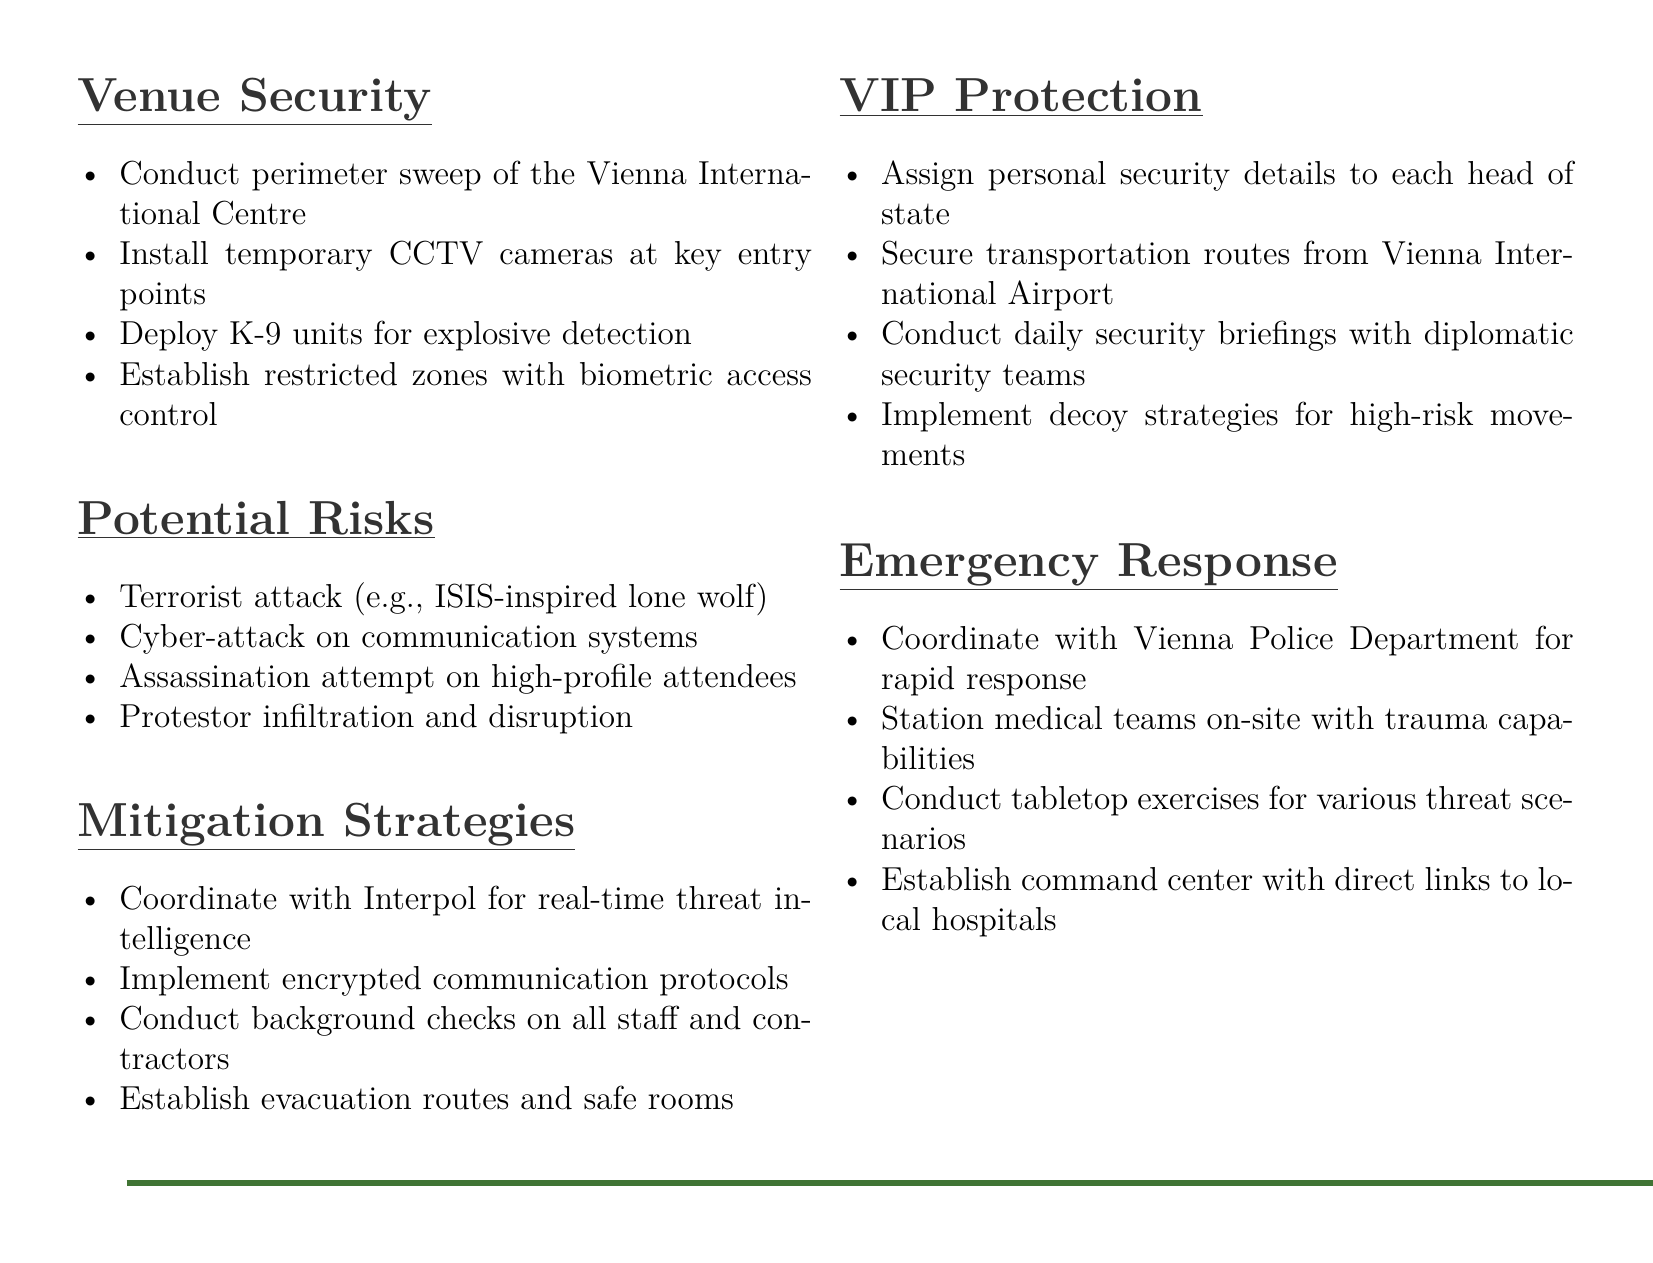What is the venue for the G20 Summit? The venue for the G20 Summit is the Vienna International Centre.
Answer: Vienna International Centre How many items are listed under "Venue Security"? There are four items listed under "Venue Security" in the checklist.
Answer: Four What potential risk involves lone wolves? The potential risk involving lone wolves is a terrorist attack (e.g., ISIS-inspired lone wolf).
Answer: Terrorist attack (e.g., ISIS-inspired lone wolf) Which authority is to be coordinated with for real-time threat intelligence? The authority to be coordinated with for real-time threat intelligence is Interpol.
Answer: Interpol What security measure is mentioned for transportation routes? The security measure mentioned for transportation routes is to secure them from Vienna International Airport.
Answer: Secure transportation routes from Vienna International Airport How many emergency response strategies are outlined? There are four emergency response strategies outlined in the document.
Answer: Four What type of units will be deployed for explosive detection? K-9 units will be deployed for explosive detection.
Answer: K-9 units What should be established for high-risk movements? Decoy strategies should be implemented for high-risk movements.
Answer: Decoy strategies What is the focus of daily security briefings? The focus of daily security briefings is with diplomatic security teams.
Answer: Diplomatic security teams 